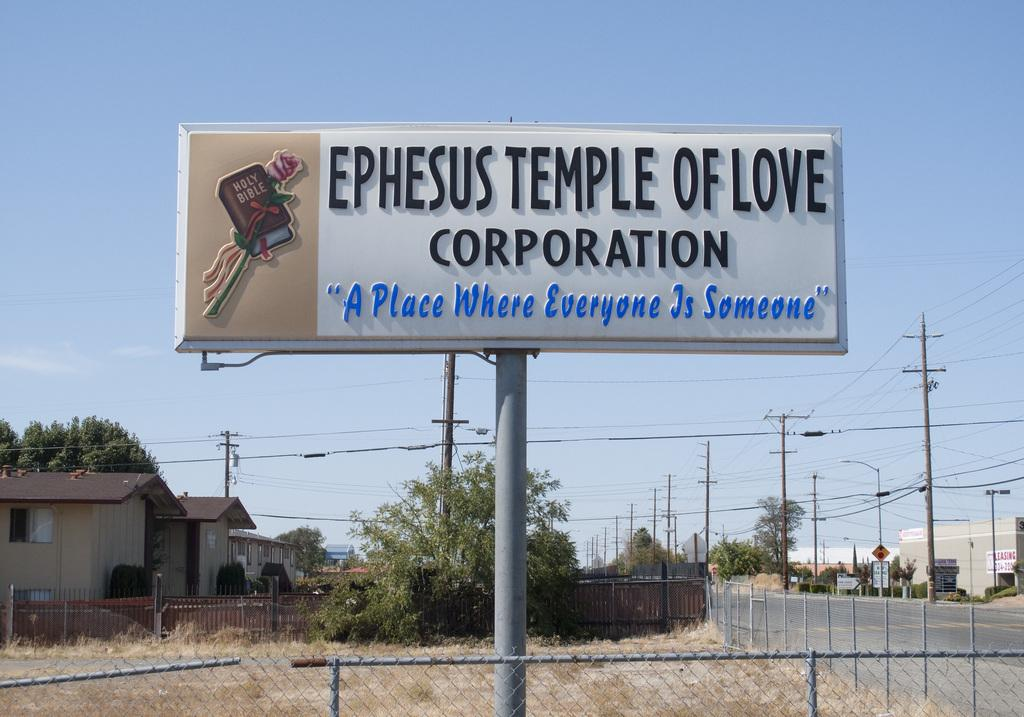<image>
Write a terse but informative summary of the picture. A large billboard says Ephesus Temple of Love Corporation. 